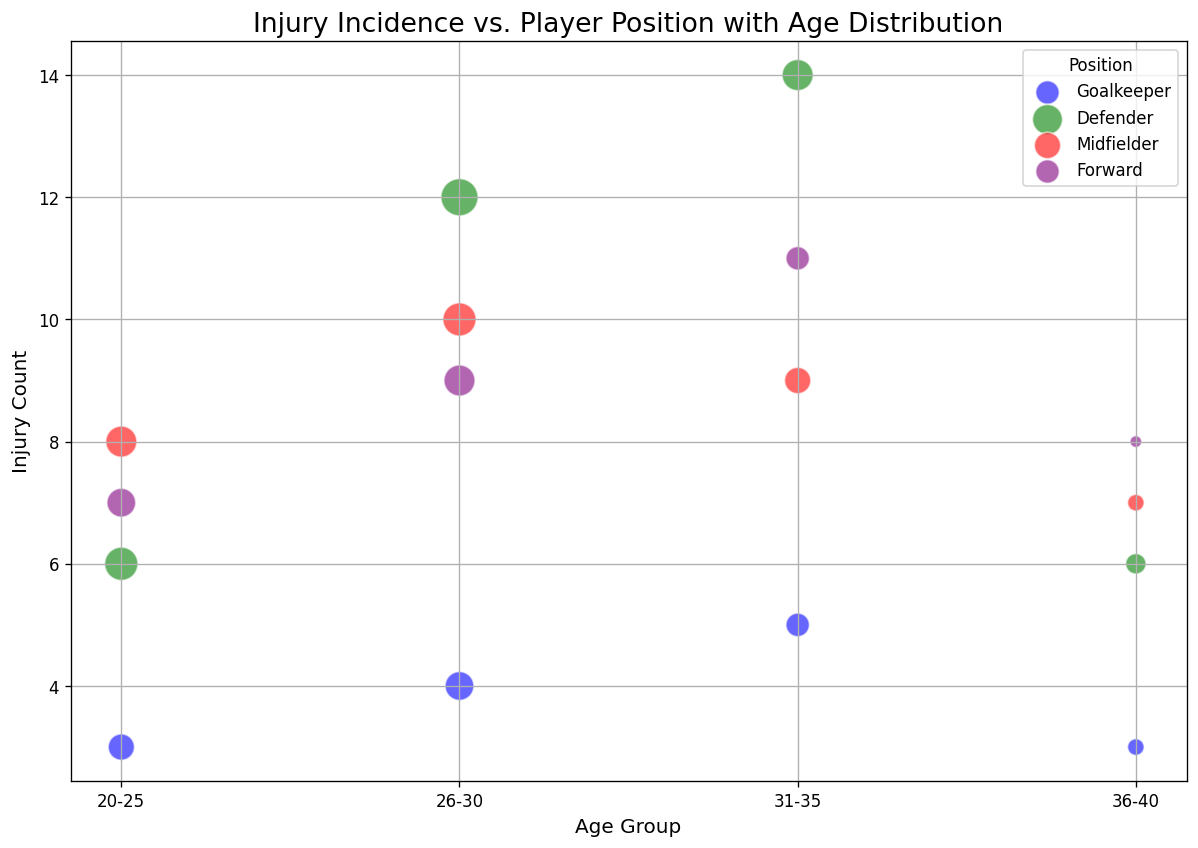What position has the highest injury count in the age group 31-35? Look at the bubble chart for the age group 31-35 and note the Injury Count for Goalkeeper, Defender, Midfielder, and Forward. The Defender position has the highest injury count.
Answer: Defender Which age group shows the highest incidence of injuries for Midfielders? Check the Injury Count of Midfielders across all age groups. The Midfielders in the age group 26-30 have the highest injury count.
Answer: 26-30 Are there more injuries among Goalkeepers or Forwards in the age group 20-25? Compare the Injury Count for Goalkeepers and Forwards in the age group 20-25. Forwards have more injuries (7) compared to Goalkeepers (3).
Answer: Forwards Which position has the largest marker size in the age group 20-25? The marker size is based on the Player Count. Check the size of the bubbles in the age group 20-25. The Defender position has the largest marker size.
Answer: Defender What is the trend in injury count for Defenders as age increases? Observe the trend in injury count for Defenders across different age groups. The Injury Count increases as the age group changes from 20-25 to 31-35 and then decreases slightly for 36-40.
Answer: Increases then Decreases Which position has the fewest players in the age group 36-40? Check the marker sizes for each position in the age group 36-40. The Forward position has the smallest marker size, indicating the fewest players.
Answer: Forward What position has the smallest increase in injury count as age groups advance from 20-25 to 31-35? Calculate the difference in injury count for each position between age groups 20-25 and 31-35. Goalkeepers have the smallest increase (from 3 to 5).
Answer: Goalkeeper What is the average injury count for Forwards across all age groups? Add the Injury Counts for Forwards (7 + 9 + 11 + 8) and divide by the number of age groups (4). (7 + 9 + 11 + 8) / 4 = 8.75.
Answer: 8.75 Which position has a decreasing trend in injury count as age increases from 31-35 to 36-40? Compare the Injury Count for each position between the age groups 31-35 and 36-40. Midfielders have a decrease from 9 to 7 in injury count.
Answer: Midfielder How does the injury count of Goalkeepers in the age group 36-40 compare to that of Defenders in the same age group? Look at the Injury Count for Goalkeepers and Defenders in age group 36-40. Goalkeepers have an Injury Count of 3, whereas Defenders have an Injury Count of 6.
Answer: Goalkeepers have fewer injuries 